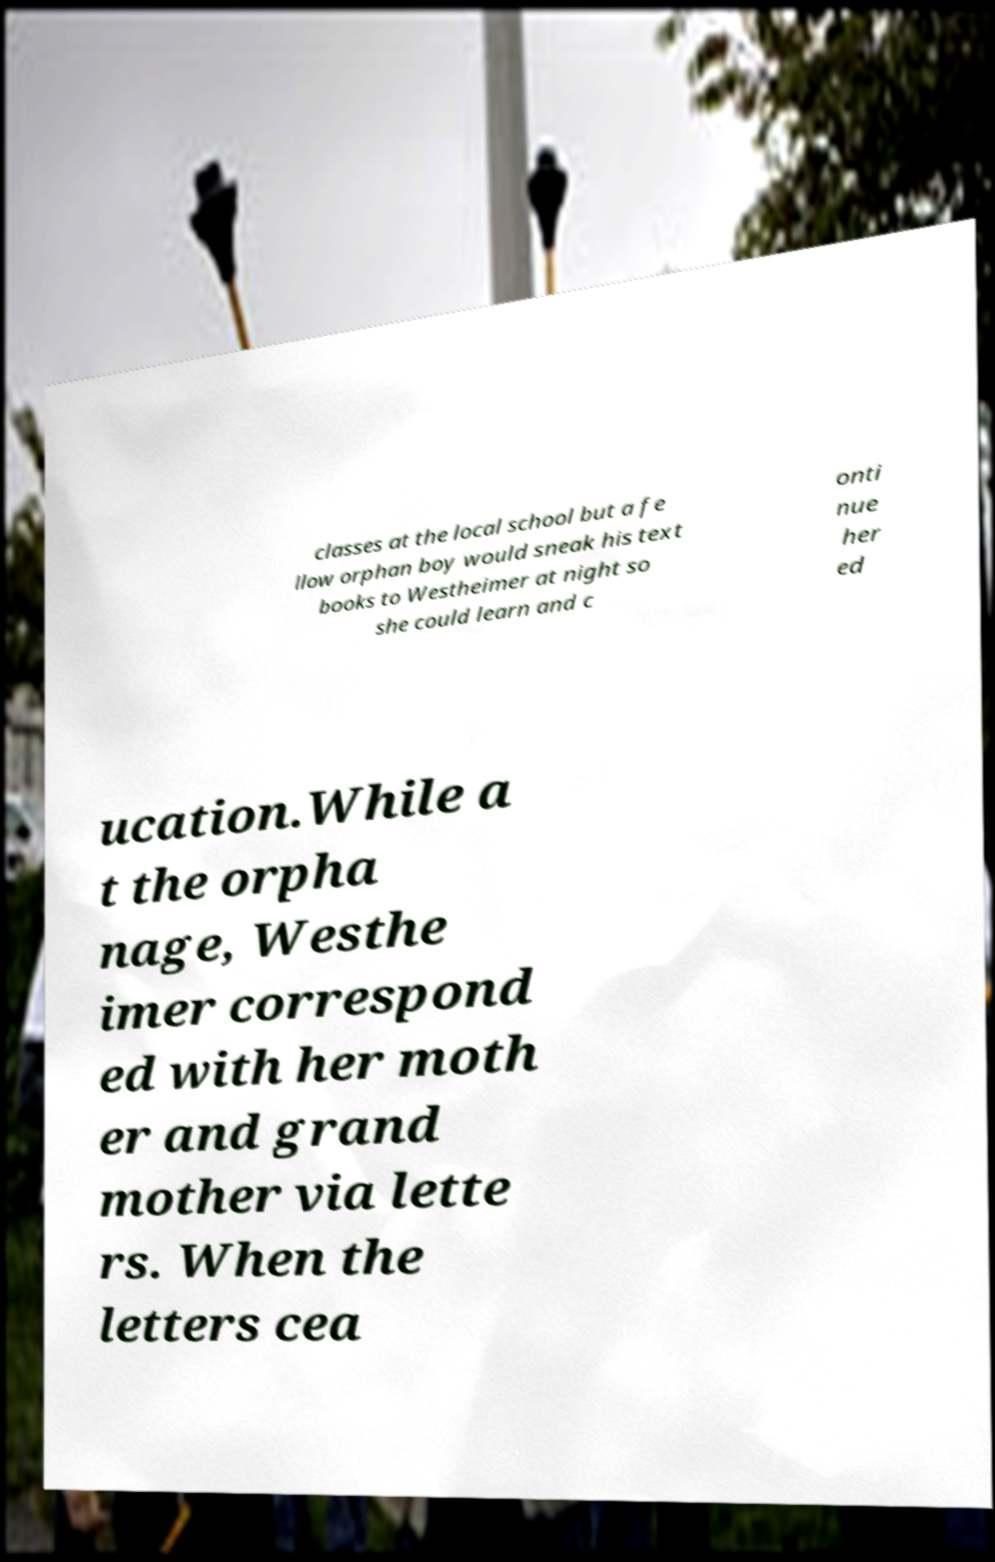Please identify and transcribe the text found in this image. classes at the local school but a fe llow orphan boy would sneak his text books to Westheimer at night so she could learn and c onti nue her ed ucation.While a t the orpha nage, Westhe imer correspond ed with her moth er and grand mother via lette rs. When the letters cea 